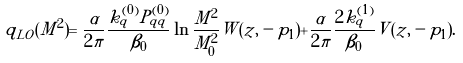Convert formula to latex. <formula><loc_0><loc_0><loc_500><loc_500>q _ { L O } ( M ^ { 2 } ) = \frac { \alpha } { 2 \pi } \frac { k _ { q } ^ { ( 0 ) } P _ { q q } ^ { ( 0 ) } } { \beta _ { 0 } } \ln \frac { M ^ { 2 } } { M ^ { 2 } _ { 0 } } W ( z , - p _ { 1 } ) + \frac { \alpha } { 2 \pi } \frac { 2 k _ { q } ^ { ( 1 ) } } { \beta _ { 0 } } V ( z , - p _ { 1 } ) .</formula> 